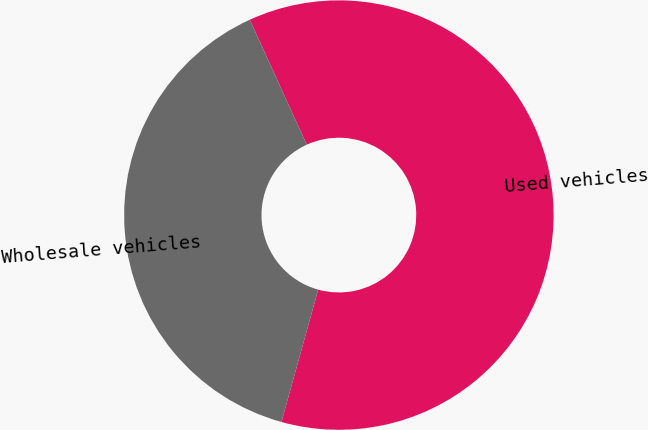Convert chart. <chart><loc_0><loc_0><loc_500><loc_500><pie_chart><fcel>Used vehicles<fcel>Wholesale vehicles<nl><fcel>61.12%<fcel>38.88%<nl></chart> 